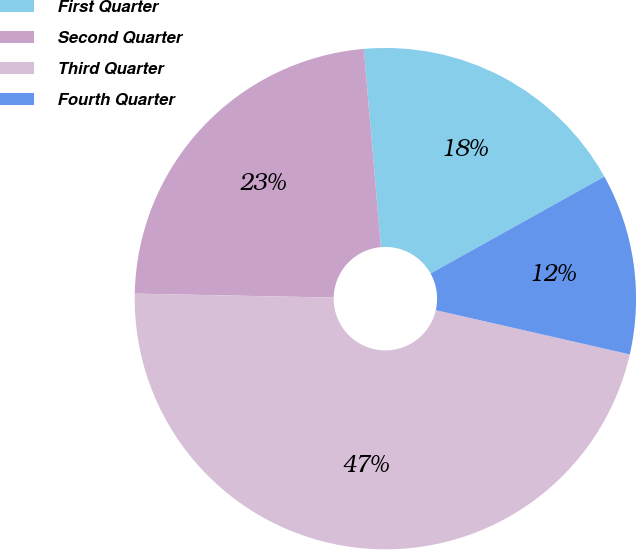Convert chart to OTSL. <chart><loc_0><loc_0><loc_500><loc_500><pie_chart><fcel>First Quarter<fcel>Second Quarter<fcel>Third Quarter<fcel>Fourth Quarter<nl><fcel>18.28%<fcel>23.31%<fcel>46.75%<fcel>11.66%<nl></chart> 